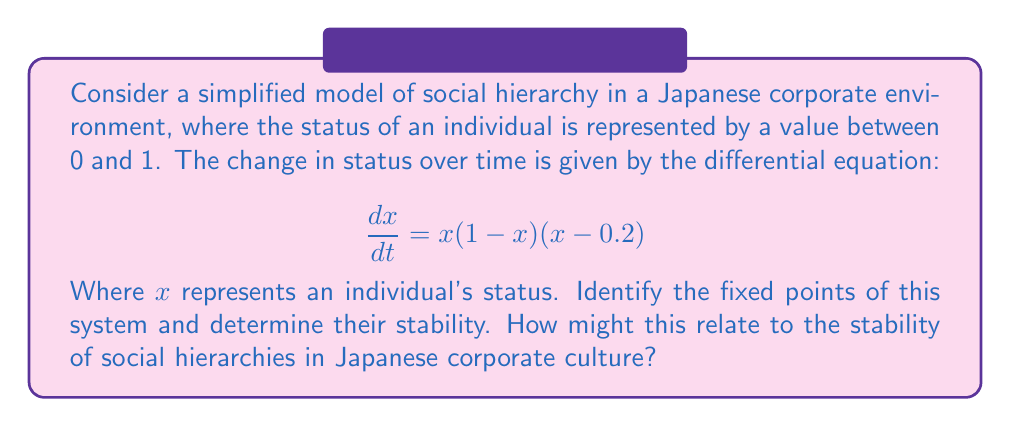Can you solve this math problem? To analyze the stability of social hierarchies using fixed point analysis:

1. Find the fixed points:
   Set $\frac{dx}{dt} = 0$
   $$x(1-x)(x-0.2) = 0$$
   Solving this equation, we get three fixed points: $x = 0$, $x = 0.2$, and $x = 1$

2. Determine stability of each fixed point:
   Calculate $\frac{d}{dx}(\frac{dx}{dt})$ and evaluate at each fixed point

   $$\frac{d}{dx}(\frac{dx}{dt}) = (1-x)(x-0.2) + x(x-0.2) + x(1-x)$$
   $$= 3x^2 - 2.2x + 0.2$$

   a. At $x = 0$:
      $\frac{d}{dx}(\frac{dx}{dt}) = 0.2 > 0$, so $x = 0$ is unstable

   b. At $x = 0.2$:
      $\frac{d}{dx}(\frac{dx}{dt}) = -0.08 < 0$, so $x = 0.2$ is stable

   c. At $x = 1$:
      $\frac{d}{dx}(\frac{dx}{dt}) = 1 > 0$, so $x = 1$ is unstable

3. Interpretation in Japanese corporate culture:
   - $x = 0$ (unstable): Represents the lowest status, individuals tend to move away from this point
   - $x = 0.2$ (stable): Represents a middle-management position, individuals tend to settle here
   - $x = 1$ (unstable): Represents the highest status, difficult to maintain this position

This model suggests that in Japanese corporate culture, there's a stable middle-management level where most individuals tend to settle, while both the lowest and highest positions are less stable.
Answer: Fixed points: $x = 0$ (unstable), $x = 0.2$ (stable), $x = 1$ (unstable). Middle-management positions are most stable in Japanese corporate hierarchy. 